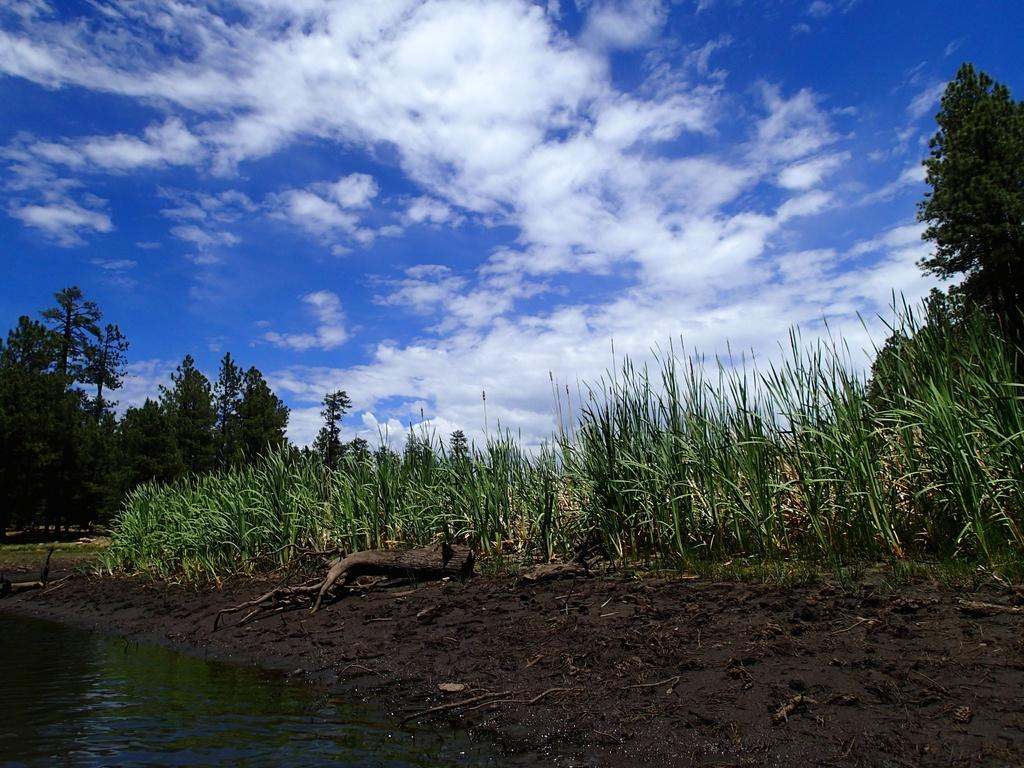What is one of the natural elements present in the image? There is water in the image. What type of material can be seen in the image? There is wood in the image. What type of vegetation is present in the image? There is grass and trees in the image. What can be seen in the background of the image? The sky is visible in the background of the image, and there are clouds present. How does the family join the water in the image? There is no family present in the image, so it is not possible to answer how they might join the water. 